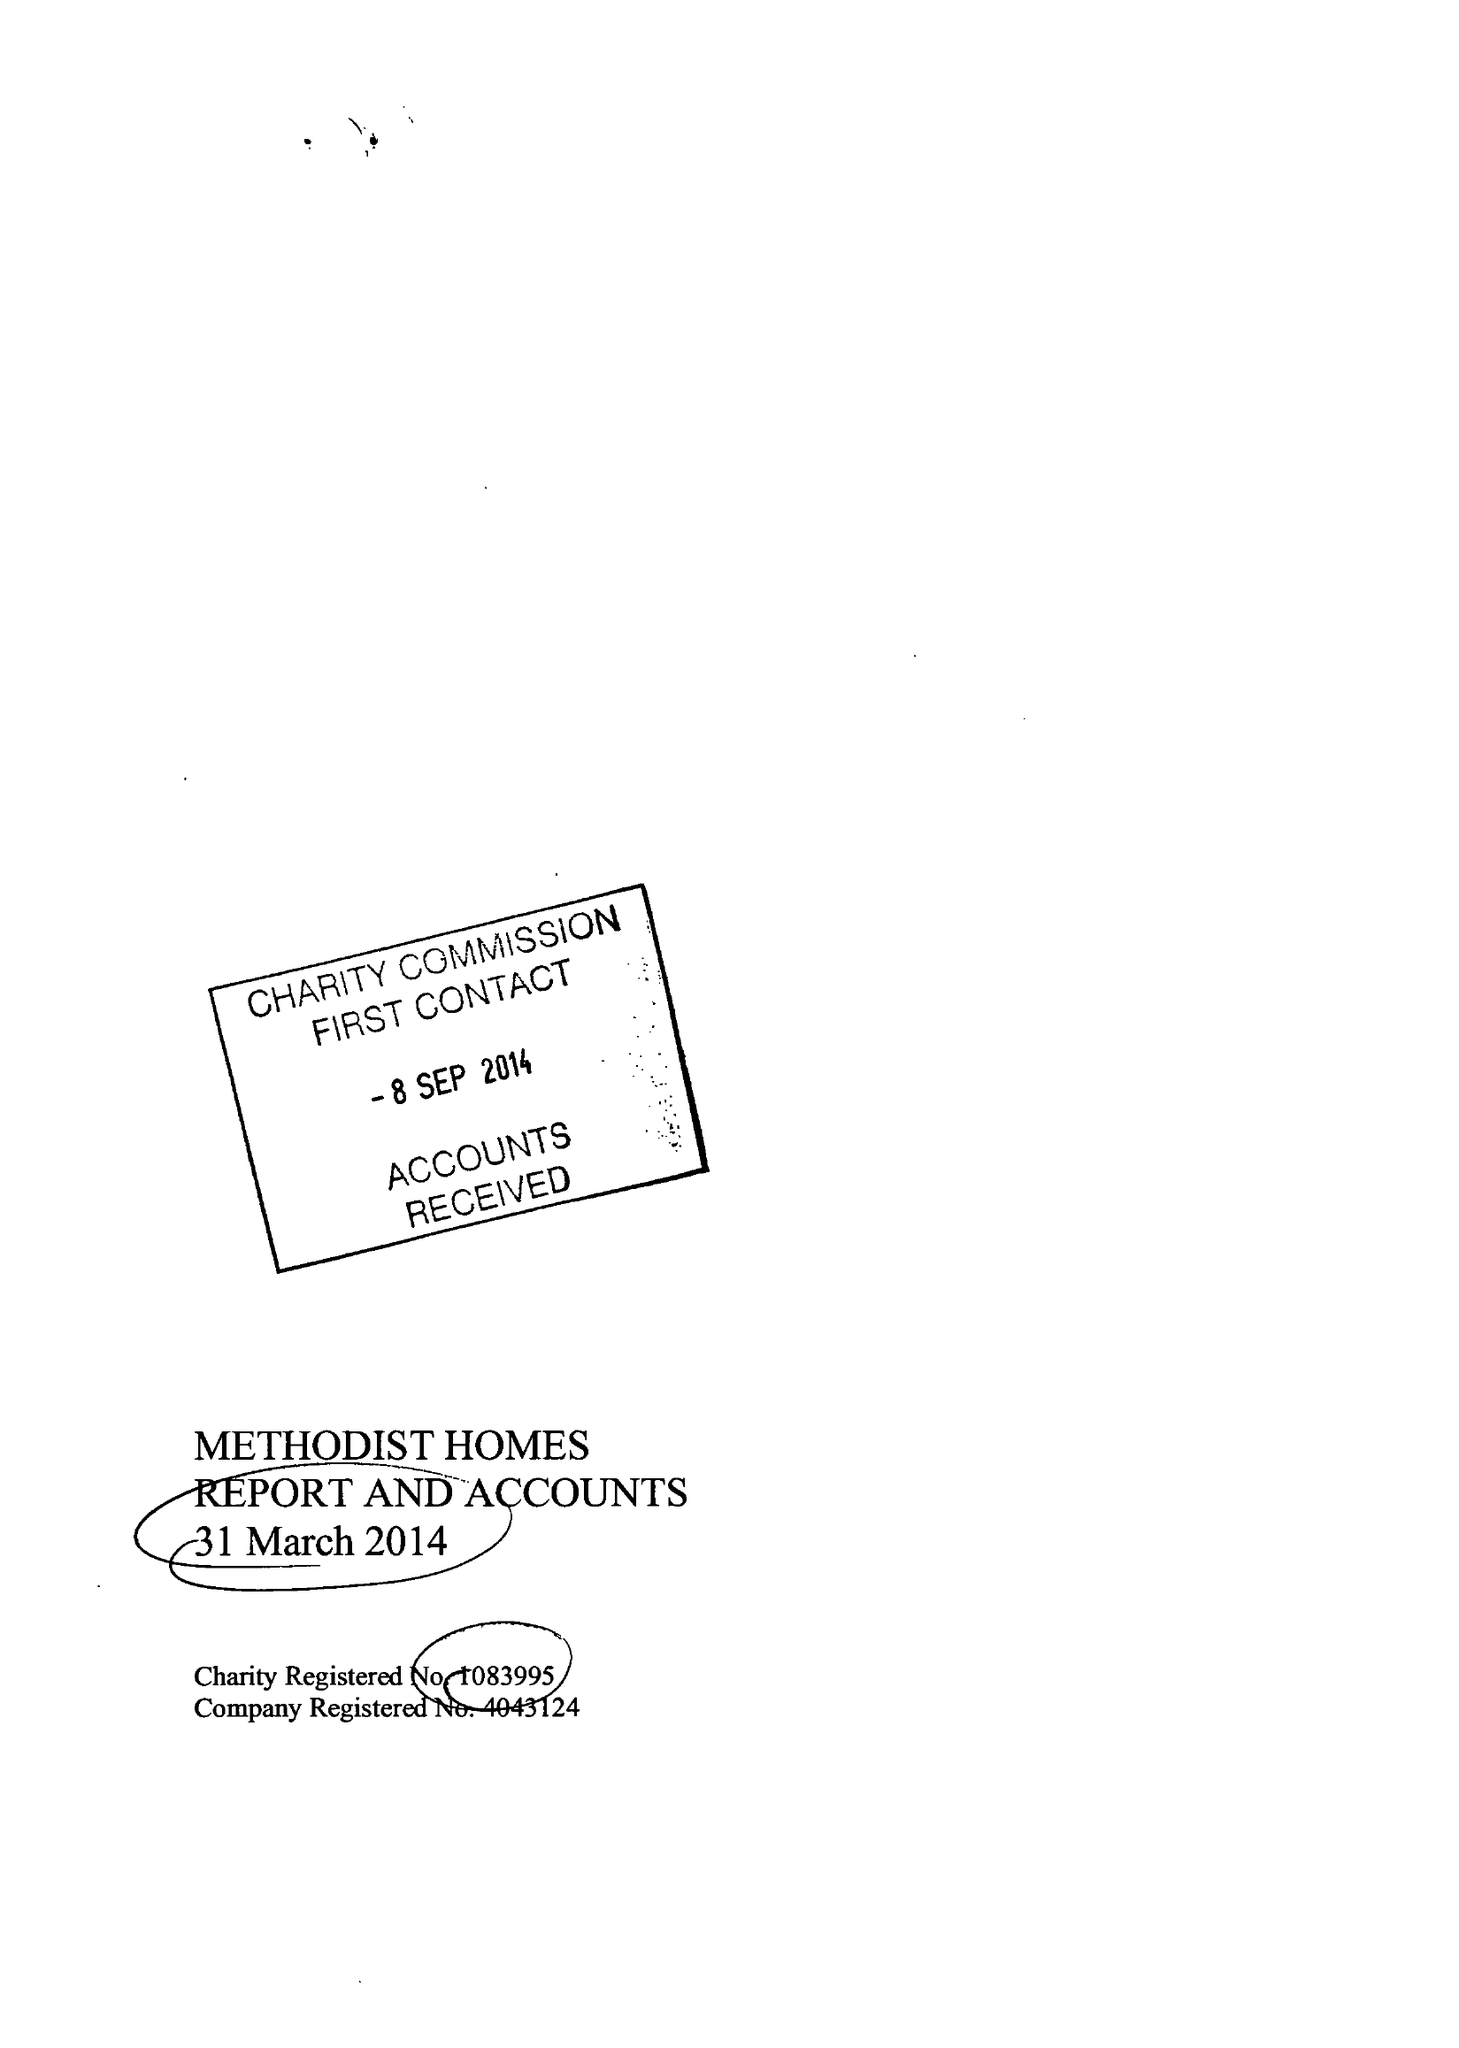What is the value for the income_annually_in_british_pounds?
Answer the question using a single word or phrase. 196500000.00 